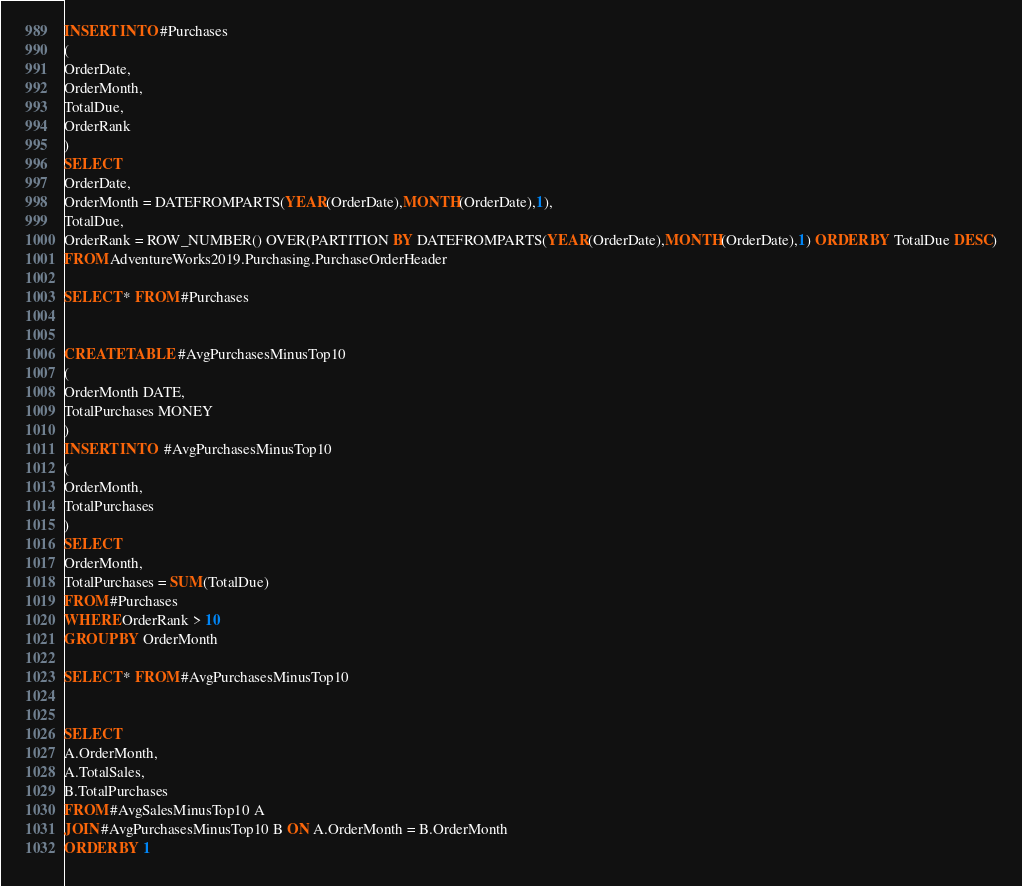<code> <loc_0><loc_0><loc_500><loc_500><_SQL_>INSERT INTO #Purchases
(
OrderDate,
OrderMonth,
TotalDue,
OrderRank
)
SELECT 
OrderDate,
OrderMonth = DATEFROMPARTS(YEAR(OrderDate),MONTH(OrderDate),1),
TotalDue,
OrderRank = ROW_NUMBER() OVER(PARTITION BY DATEFROMPARTS(YEAR(OrderDate),MONTH(OrderDate),1) ORDER BY TotalDue DESC)
FROM AdventureWorks2019.Purchasing.PurchaseOrderHeader

SELECT * FROM #Purchases


CREATE TABLE #AvgPurchasesMinusTop10
(
OrderMonth DATE,
TotalPurchases MONEY
)
INSERT INTO  #AvgPurchasesMinusTop10
(
OrderMonth,
TotalPurchases
)
SELECT
OrderMonth,
TotalPurchases = SUM(TotalDue)
FROM #Purchases
WHERE OrderRank > 10
GROUP BY OrderMonth

SELECT * FROM #AvgPurchasesMinusTop10


SELECT
A.OrderMonth,
A.TotalSales,
B.TotalPurchases
FROM #AvgSalesMinusTop10 A
JOIN #AvgPurchasesMinusTop10 B ON A.OrderMonth = B.OrderMonth
ORDER BY 1
</code> 